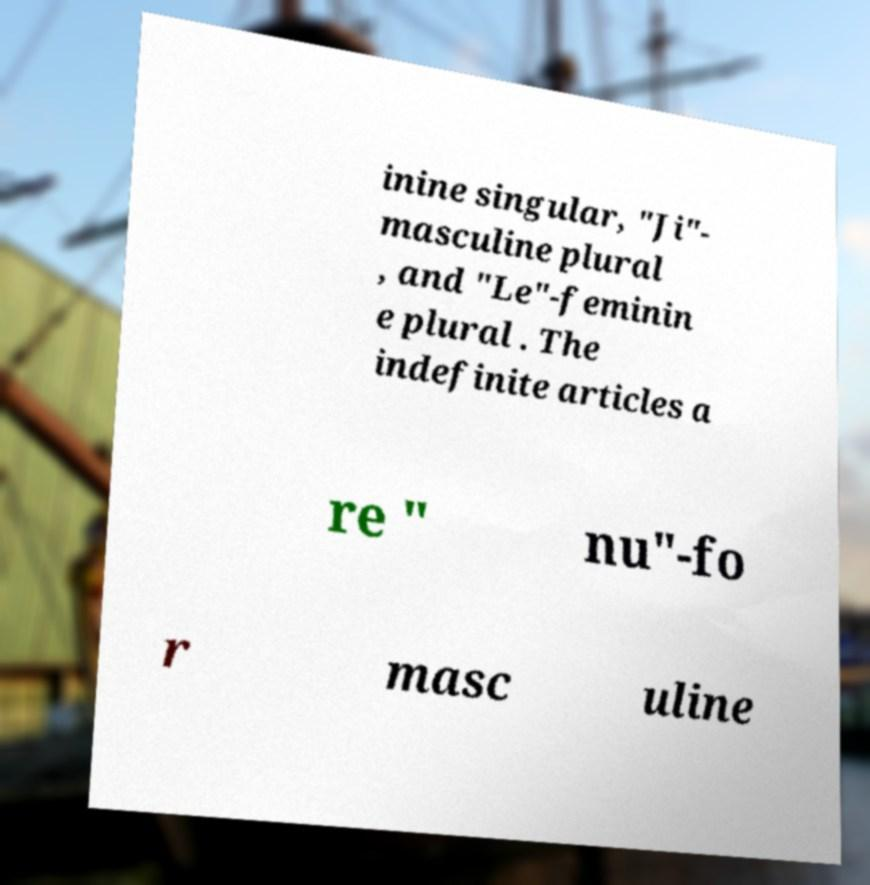What messages or text are displayed in this image? I need them in a readable, typed format. inine singular, "Ji"- masculine plural , and "Le"-feminin e plural . The indefinite articles a re " nu"-fo r masc uline 